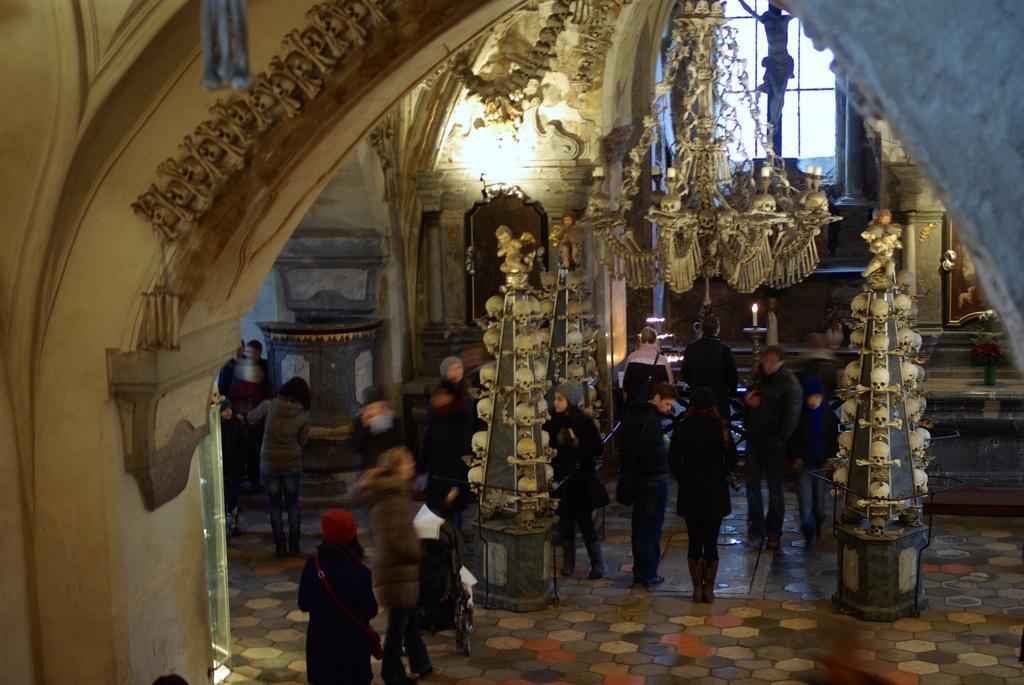How would you summarize this image in a sentence or two? In this picture I can observe some people standing on the floor. There are men and women in this picture. I can observe chandelier on the right side. In the background there is a window. 